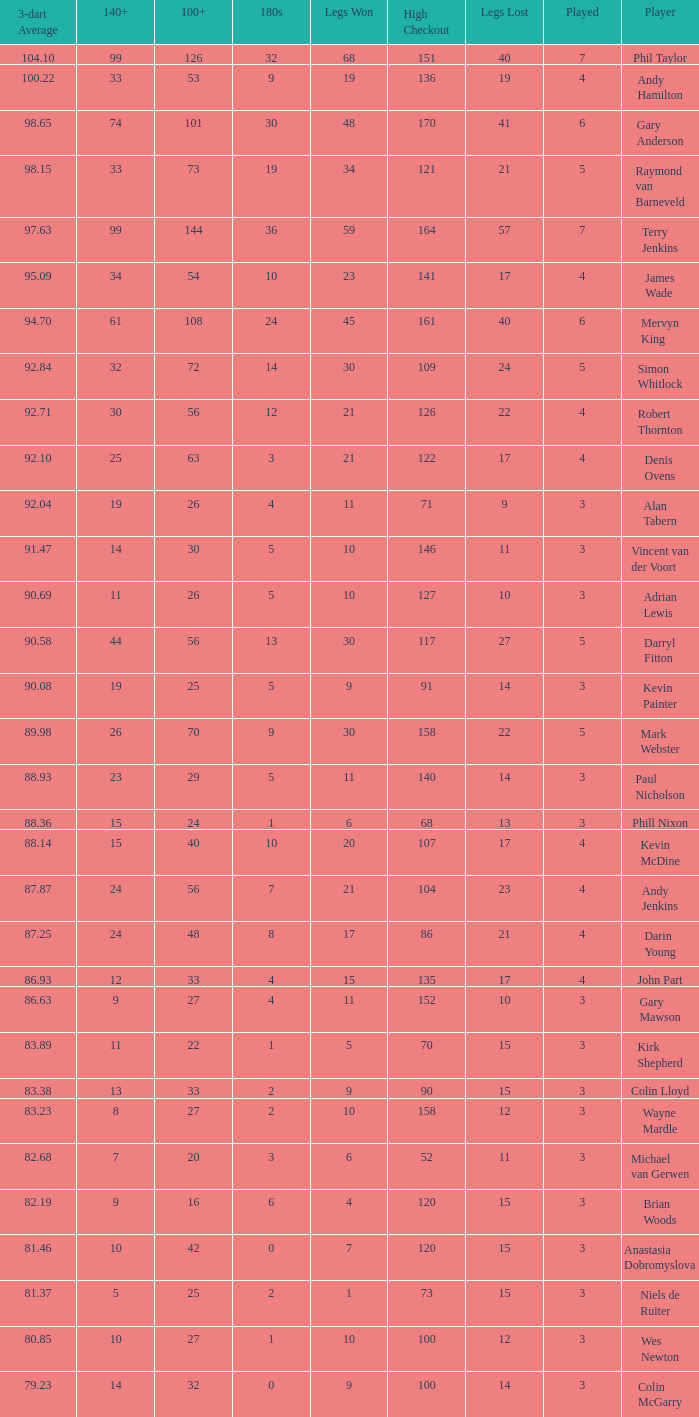What is the number of high checkout when legs Lost is 17, 140+ is 15, and played is larger than 4? None. 